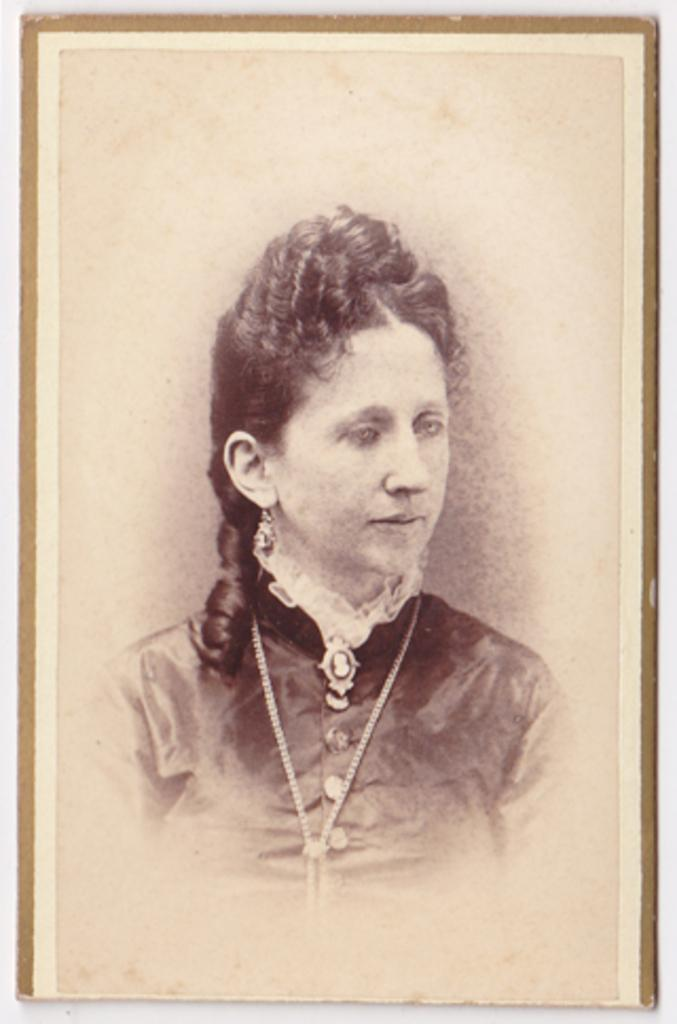What object is present in the image that typically holds a photograph? There is a photo frame in the image. What can be seen inside the photo frame? There is a person in the photo frame. What is the color of the background in the image? The background of the image is white in color. How many kittens can be seen sneezing in the image? There are no kittens or sneezing} in the image. 